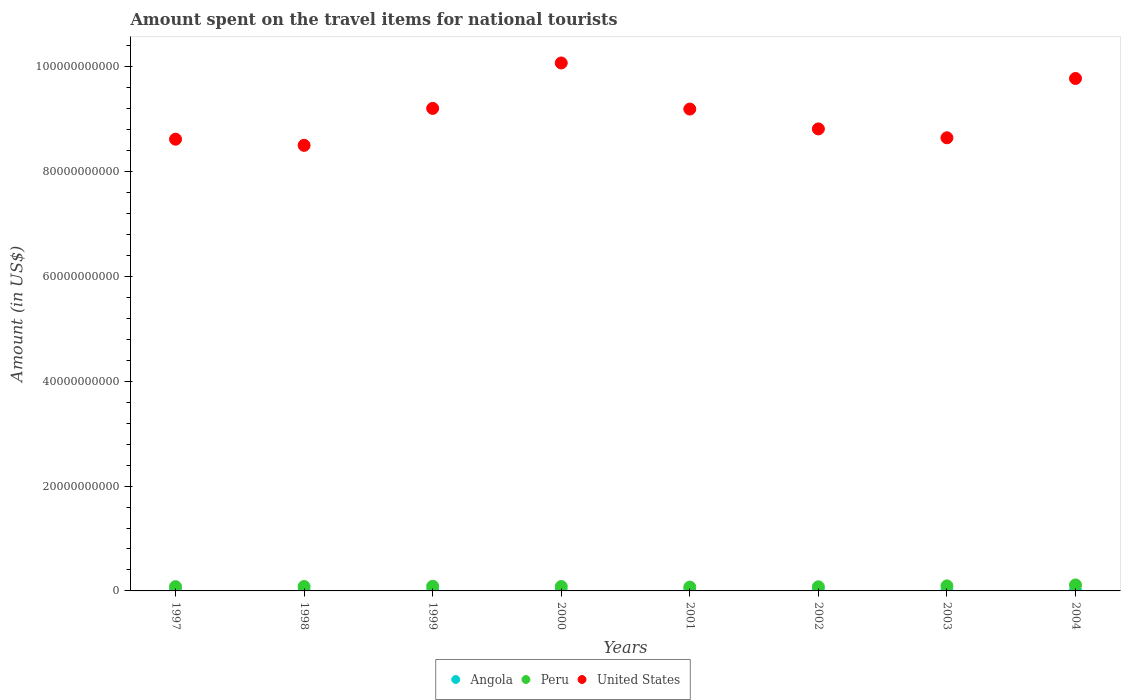Is the number of dotlines equal to the number of legend labels?
Make the answer very short. Yes. What is the amount spent on the travel items for national tourists in Peru in 2001?
Give a very brief answer. 7.33e+08. Across all years, what is the maximum amount spent on the travel items for national tourists in United States?
Ensure brevity in your answer.  1.01e+11. Across all years, what is the minimum amount spent on the travel items for national tourists in Peru?
Your answer should be compact. 7.33e+08. In which year was the amount spent on the travel items for national tourists in Angola maximum?
Your answer should be compact. 2004. In which year was the amount spent on the travel items for national tourists in Angola minimum?
Your answer should be very brief. 1998. What is the total amount spent on the travel items for national tourists in United States in the graph?
Keep it short and to the point. 7.28e+11. What is the difference between the amount spent on the travel items for national tourists in United States in 1998 and that in 2004?
Make the answer very short. -1.28e+1. What is the difference between the amount spent on the travel items for national tourists in Peru in 2004 and the amount spent on the travel items for national tourists in Angola in 1999?
Provide a succinct answer. 1.13e+09. What is the average amount spent on the travel items for national tourists in Angola per year?
Provide a succinct answer. 2.78e+07. In the year 2001, what is the difference between the amount spent on the travel items for national tourists in United States and amount spent on the travel items for national tourists in Peru?
Provide a short and direct response. 9.12e+1. What is the ratio of the amount spent on the travel items for national tourists in Peru in 2000 to that in 2004?
Provide a succinct answer. 0.73. Is the amount spent on the travel items for national tourists in United States in 1997 less than that in 2004?
Provide a short and direct response. Yes. Is the difference between the amount spent on the travel items for national tourists in United States in 1999 and 2000 greater than the difference between the amount spent on the travel items for national tourists in Peru in 1999 and 2000?
Your answer should be very brief. No. What is the difference between the highest and the second highest amount spent on the travel items for national tourists in Peru?
Provide a short and direct response. 1.79e+08. What is the difference between the highest and the lowest amount spent on the travel items for national tourists in United States?
Keep it short and to the point. 1.57e+1. Is the sum of the amount spent on the travel items for national tourists in United States in 1999 and 2003 greater than the maximum amount spent on the travel items for national tourists in Angola across all years?
Make the answer very short. Yes. Is the amount spent on the travel items for national tourists in Peru strictly less than the amount spent on the travel items for national tourists in United States over the years?
Offer a terse response. Yes. How many years are there in the graph?
Your response must be concise. 8. Are the values on the major ticks of Y-axis written in scientific E-notation?
Your response must be concise. No. Where does the legend appear in the graph?
Keep it short and to the point. Bottom center. What is the title of the graph?
Provide a short and direct response. Amount spent on the travel items for national tourists. What is the label or title of the X-axis?
Offer a terse response. Years. What is the Amount (in US$) in Angola in 1997?
Offer a very short reply. 9.00e+06. What is the Amount (in US$) in Peru in 1997?
Make the answer very short. 8.16e+08. What is the Amount (in US$) of United States in 1997?
Give a very brief answer. 8.62e+1. What is the Amount (in US$) of Peru in 1998?
Provide a succinct answer. 8.45e+08. What is the Amount (in US$) in United States in 1998?
Your response must be concise. 8.50e+1. What is the Amount (in US$) of Angola in 1999?
Ensure brevity in your answer.  1.30e+07. What is the Amount (in US$) of Peru in 1999?
Give a very brief answer. 8.90e+08. What is the Amount (in US$) of United States in 1999?
Your answer should be compact. 9.20e+1. What is the Amount (in US$) in Angola in 2000?
Provide a succinct answer. 1.80e+07. What is the Amount (in US$) in Peru in 2000?
Provide a succinct answer. 8.37e+08. What is the Amount (in US$) of United States in 2000?
Your response must be concise. 1.01e+11. What is the Amount (in US$) of Angola in 2001?
Provide a short and direct response. 2.20e+07. What is the Amount (in US$) in Peru in 2001?
Make the answer very short. 7.33e+08. What is the Amount (in US$) in United States in 2001?
Keep it short and to the point. 9.19e+1. What is the Amount (in US$) in Angola in 2002?
Provide a succinct answer. 3.70e+07. What is the Amount (in US$) in Peru in 2002?
Provide a short and direct response. 7.87e+08. What is the Amount (in US$) of United States in 2002?
Ensure brevity in your answer.  8.81e+1. What is the Amount (in US$) in Angola in 2003?
Make the answer very short. 4.90e+07. What is the Amount (in US$) in Peru in 2003?
Your answer should be very brief. 9.63e+08. What is the Amount (in US$) in United States in 2003?
Ensure brevity in your answer.  8.64e+1. What is the Amount (in US$) in Angola in 2004?
Your answer should be very brief. 6.60e+07. What is the Amount (in US$) in Peru in 2004?
Offer a terse response. 1.14e+09. What is the Amount (in US$) in United States in 2004?
Your answer should be very brief. 9.78e+1. Across all years, what is the maximum Amount (in US$) in Angola?
Your answer should be very brief. 6.60e+07. Across all years, what is the maximum Amount (in US$) in Peru?
Your answer should be very brief. 1.14e+09. Across all years, what is the maximum Amount (in US$) of United States?
Your answer should be compact. 1.01e+11. Across all years, what is the minimum Amount (in US$) of Peru?
Ensure brevity in your answer.  7.33e+08. Across all years, what is the minimum Amount (in US$) of United States?
Keep it short and to the point. 8.50e+1. What is the total Amount (in US$) of Angola in the graph?
Give a very brief answer. 2.22e+08. What is the total Amount (in US$) of Peru in the graph?
Provide a short and direct response. 7.01e+09. What is the total Amount (in US$) of United States in the graph?
Provide a succinct answer. 7.28e+11. What is the difference between the Amount (in US$) in Angola in 1997 and that in 1998?
Your response must be concise. 1.00e+06. What is the difference between the Amount (in US$) in Peru in 1997 and that in 1998?
Provide a succinct answer. -2.90e+07. What is the difference between the Amount (in US$) in United States in 1997 and that in 1998?
Offer a terse response. 1.17e+09. What is the difference between the Amount (in US$) of Angola in 1997 and that in 1999?
Provide a succinct answer. -4.00e+06. What is the difference between the Amount (in US$) of Peru in 1997 and that in 1999?
Keep it short and to the point. -7.40e+07. What is the difference between the Amount (in US$) of United States in 1997 and that in 1999?
Provide a short and direct response. -5.88e+09. What is the difference between the Amount (in US$) of Angola in 1997 and that in 2000?
Offer a very short reply. -9.00e+06. What is the difference between the Amount (in US$) in Peru in 1997 and that in 2000?
Your answer should be compact. -2.10e+07. What is the difference between the Amount (in US$) of United States in 1997 and that in 2000?
Provide a succinct answer. -1.45e+1. What is the difference between the Amount (in US$) in Angola in 1997 and that in 2001?
Your answer should be very brief. -1.30e+07. What is the difference between the Amount (in US$) in Peru in 1997 and that in 2001?
Provide a short and direct response. 8.30e+07. What is the difference between the Amount (in US$) in United States in 1997 and that in 2001?
Give a very brief answer. -5.75e+09. What is the difference between the Amount (in US$) of Angola in 1997 and that in 2002?
Ensure brevity in your answer.  -2.80e+07. What is the difference between the Amount (in US$) in Peru in 1997 and that in 2002?
Give a very brief answer. 2.90e+07. What is the difference between the Amount (in US$) of United States in 1997 and that in 2002?
Give a very brief answer. -1.96e+09. What is the difference between the Amount (in US$) in Angola in 1997 and that in 2003?
Your answer should be very brief. -4.00e+07. What is the difference between the Amount (in US$) of Peru in 1997 and that in 2003?
Make the answer very short. -1.47e+08. What is the difference between the Amount (in US$) in United States in 1997 and that in 2003?
Your response must be concise. -2.69e+08. What is the difference between the Amount (in US$) in Angola in 1997 and that in 2004?
Offer a terse response. -5.70e+07. What is the difference between the Amount (in US$) of Peru in 1997 and that in 2004?
Keep it short and to the point. -3.26e+08. What is the difference between the Amount (in US$) in United States in 1997 and that in 2004?
Make the answer very short. -1.16e+1. What is the difference between the Amount (in US$) in Angola in 1998 and that in 1999?
Your response must be concise. -5.00e+06. What is the difference between the Amount (in US$) of Peru in 1998 and that in 1999?
Offer a very short reply. -4.50e+07. What is the difference between the Amount (in US$) of United States in 1998 and that in 1999?
Your answer should be very brief. -7.05e+09. What is the difference between the Amount (in US$) in Angola in 1998 and that in 2000?
Offer a terse response. -1.00e+07. What is the difference between the Amount (in US$) in Peru in 1998 and that in 2000?
Ensure brevity in your answer.  8.00e+06. What is the difference between the Amount (in US$) in United States in 1998 and that in 2000?
Give a very brief answer. -1.57e+1. What is the difference between the Amount (in US$) in Angola in 1998 and that in 2001?
Provide a short and direct response. -1.40e+07. What is the difference between the Amount (in US$) of Peru in 1998 and that in 2001?
Your response must be concise. 1.12e+08. What is the difference between the Amount (in US$) of United States in 1998 and that in 2001?
Give a very brief answer. -6.92e+09. What is the difference between the Amount (in US$) in Angola in 1998 and that in 2002?
Offer a terse response. -2.90e+07. What is the difference between the Amount (in US$) of Peru in 1998 and that in 2002?
Make the answer very short. 5.80e+07. What is the difference between the Amount (in US$) of United States in 1998 and that in 2002?
Provide a short and direct response. -3.14e+09. What is the difference between the Amount (in US$) of Angola in 1998 and that in 2003?
Provide a succinct answer. -4.10e+07. What is the difference between the Amount (in US$) in Peru in 1998 and that in 2003?
Your answer should be very brief. -1.18e+08. What is the difference between the Amount (in US$) of United States in 1998 and that in 2003?
Provide a short and direct response. -1.44e+09. What is the difference between the Amount (in US$) in Angola in 1998 and that in 2004?
Offer a terse response. -5.80e+07. What is the difference between the Amount (in US$) in Peru in 1998 and that in 2004?
Your response must be concise. -2.97e+08. What is the difference between the Amount (in US$) in United States in 1998 and that in 2004?
Your response must be concise. -1.28e+1. What is the difference between the Amount (in US$) in Angola in 1999 and that in 2000?
Offer a very short reply. -5.00e+06. What is the difference between the Amount (in US$) of Peru in 1999 and that in 2000?
Keep it short and to the point. 5.30e+07. What is the difference between the Amount (in US$) of United States in 1999 and that in 2000?
Your answer should be very brief. -8.67e+09. What is the difference between the Amount (in US$) of Angola in 1999 and that in 2001?
Your answer should be very brief. -9.00e+06. What is the difference between the Amount (in US$) in Peru in 1999 and that in 2001?
Provide a succinct answer. 1.57e+08. What is the difference between the Amount (in US$) of United States in 1999 and that in 2001?
Provide a succinct answer. 1.28e+08. What is the difference between the Amount (in US$) in Angola in 1999 and that in 2002?
Your response must be concise. -2.40e+07. What is the difference between the Amount (in US$) of Peru in 1999 and that in 2002?
Your response must be concise. 1.03e+08. What is the difference between the Amount (in US$) of United States in 1999 and that in 2002?
Keep it short and to the point. 3.91e+09. What is the difference between the Amount (in US$) of Angola in 1999 and that in 2003?
Your answer should be very brief. -3.60e+07. What is the difference between the Amount (in US$) of Peru in 1999 and that in 2003?
Provide a succinct answer. -7.30e+07. What is the difference between the Amount (in US$) of United States in 1999 and that in 2003?
Offer a terse response. 5.61e+09. What is the difference between the Amount (in US$) of Angola in 1999 and that in 2004?
Your answer should be very brief. -5.30e+07. What is the difference between the Amount (in US$) of Peru in 1999 and that in 2004?
Make the answer very short. -2.52e+08. What is the difference between the Amount (in US$) in United States in 1999 and that in 2004?
Keep it short and to the point. -5.71e+09. What is the difference between the Amount (in US$) in Angola in 2000 and that in 2001?
Your response must be concise. -4.00e+06. What is the difference between the Amount (in US$) of Peru in 2000 and that in 2001?
Your answer should be very brief. 1.04e+08. What is the difference between the Amount (in US$) of United States in 2000 and that in 2001?
Ensure brevity in your answer.  8.79e+09. What is the difference between the Amount (in US$) of Angola in 2000 and that in 2002?
Give a very brief answer. -1.90e+07. What is the difference between the Amount (in US$) in United States in 2000 and that in 2002?
Offer a very short reply. 1.26e+1. What is the difference between the Amount (in US$) of Angola in 2000 and that in 2003?
Keep it short and to the point. -3.10e+07. What is the difference between the Amount (in US$) of Peru in 2000 and that in 2003?
Provide a succinct answer. -1.26e+08. What is the difference between the Amount (in US$) of United States in 2000 and that in 2003?
Your answer should be very brief. 1.43e+1. What is the difference between the Amount (in US$) in Angola in 2000 and that in 2004?
Your answer should be compact. -4.80e+07. What is the difference between the Amount (in US$) in Peru in 2000 and that in 2004?
Give a very brief answer. -3.05e+08. What is the difference between the Amount (in US$) in United States in 2000 and that in 2004?
Your answer should be very brief. 2.96e+09. What is the difference between the Amount (in US$) in Angola in 2001 and that in 2002?
Provide a succinct answer. -1.50e+07. What is the difference between the Amount (in US$) in Peru in 2001 and that in 2002?
Ensure brevity in your answer.  -5.40e+07. What is the difference between the Amount (in US$) of United States in 2001 and that in 2002?
Your answer should be compact. 3.79e+09. What is the difference between the Amount (in US$) in Angola in 2001 and that in 2003?
Your answer should be compact. -2.70e+07. What is the difference between the Amount (in US$) in Peru in 2001 and that in 2003?
Keep it short and to the point. -2.30e+08. What is the difference between the Amount (in US$) in United States in 2001 and that in 2003?
Ensure brevity in your answer.  5.48e+09. What is the difference between the Amount (in US$) in Angola in 2001 and that in 2004?
Provide a short and direct response. -4.40e+07. What is the difference between the Amount (in US$) in Peru in 2001 and that in 2004?
Make the answer very short. -4.09e+08. What is the difference between the Amount (in US$) of United States in 2001 and that in 2004?
Your response must be concise. -5.84e+09. What is the difference between the Amount (in US$) of Angola in 2002 and that in 2003?
Offer a terse response. -1.20e+07. What is the difference between the Amount (in US$) of Peru in 2002 and that in 2003?
Provide a short and direct response. -1.76e+08. What is the difference between the Amount (in US$) of United States in 2002 and that in 2003?
Your answer should be compact. 1.69e+09. What is the difference between the Amount (in US$) of Angola in 2002 and that in 2004?
Your response must be concise. -2.90e+07. What is the difference between the Amount (in US$) of Peru in 2002 and that in 2004?
Your response must be concise. -3.55e+08. What is the difference between the Amount (in US$) in United States in 2002 and that in 2004?
Your answer should be very brief. -9.62e+09. What is the difference between the Amount (in US$) in Angola in 2003 and that in 2004?
Provide a short and direct response. -1.70e+07. What is the difference between the Amount (in US$) of Peru in 2003 and that in 2004?
Give a very brief answer. -1.79e+08. What is the difference between the Amount (in US$) in United States in 2003 and that in 2004?
Give a very brief answer. -1.13e+1. What is the difference between the Amount (in US$) in Angola in 1997 and the Amount (in US$) in Peru in 1998?
Ensure brevity in your answer.  -8.36e+08. What is the difference between the Amount (in US$) of Angola in 1997 and the Amount (in US$) of United States in 1998?
Your answer should be compact. -8.50e+1. What is the difference between the Amount (in US$) in Peru in 1997 and the Amount (in US$) in United States in 1998?
Your response must be concise. -8.42e+1. What is the difference between the Amount (in US$) of Angola in 1997 and the Amount (in US$) of Peru in 1999?
Your response must be concise. -8.81e+08. What is the difference between the Amount (in US$) in Angola in 1997 and the Amount (in US$) in United States in 1999?
Keep it short and to the point. -9.20e+1. What is the difference between the Amount (in US$) of Peru in 1997 and the Amount (in US$) of United States in 1999?
Provide a short and direct response. -9.12e+1. What is the difference between the Amount (in US$) of Angola in 1997 and the Amount (in US$) of Peru in 2000?
Give a very brief answer. -8.28e+08. What is the difference between the Amount (in US$) in Angola in 1997 and the Amount (in US$) in United States in 2000?
Ensure brevity in your answer.  -1.01e+11. What is the difference between the Amount (in US$) in Peru in 1997 and the Amount (in US$) in United States in 2000?
Ensure brevity in your answer.  -9.99e+1. What is the difference between the Amount (in US$) in Angola in 1997 and the Amount (in US$) in Peru in 2001?
Your answer should be compact. -7.24e+08. What is the difference between the Amount (in US$) of Angola in 1997 and the Amount (in US$) of United States in 2001?
Make the answer very short. -9.19e+1. What is the difference between the Amount (in US$) in Peru in 1997 and the Amount (in US$) in United States in 2001?
Your answer should be compact. -9.11e+1. What is the difference between the Amount (in US$) of Angola in 1997 and the Amount (in US$) of Peru in 2002?
Your answer should be very brief. -7.78e+08. What is the difference between the Amount (in US$) of Angola in 1997 and the Amount (in US$) of United States in 2002?
Your response must be concise. -8.81e+1. What is the difference between the Amount (in US$) in Peru in 1997 and the Amount (in US$) in United States in 2002?
Give a very brief answer. -8.73e+1. What is the difference between the Amount (in US$) of Angola in 1997 and the Amount (in US$) of Peru in 2003?
Your response must be concise. -9.54e+08. What is the difference between the Amount (in US$) in Angola in 1997 and the Amount (in US$) in United States in 2003?
Make the answer very short. -8.64e+1. What is the difference between the Amount (in US$) in Peru in 1997 and the Amount (in US$) in United States in 2003?
Keep it short and to the point. -8.56e+1. What is the difference between the Amount (in US$) in Angola in 1997 and the Amount (in US$) in Peru in 2004?
Your response must be concise. -1.13e+09. What is the difference between the Amount (in US$) in Angola in 1997 and the Amount (in US$) in United States in 2004?
Offer a terse response. -9.77e+1. What is the difference between the Amount (in US$) in Peru in 1997 and the Amount (in US$) in United States in 2004?
Your response must be concise. -9.69e+1. What is the difference between the Amount (in US$) of Angola in 1998 and the Amount (in US$) of Peru in 1999?
Provide a short and direct response. -8.82e+08. What is the difference between the Amount (in US$) of Angola in 1998 and the Amount (in US$) of United States in 1999?
Make the answer very short. -9.20e+1. What is the difference between the Amount (in US$) in Peru in 1998 and the Amount (in US$) in United States in 1999?
Make the answer very short. -9.12e+1. What is the difference between the Amount (in US$) in Angola in 1998 and the Amount (in US$) in Peru in 2000?
Ensure brevity in your answer.  -8.29e+08. What is the difference between the Amount (in US$) of Angola in 1998 and the Amount (in US$) of United States in 2000?
Your answer should be compact. -1.01e+11. What is the difference between the Amount (in US$) in Peru in 1998 and the Amount (in US$) in United States in 2000?
Your answer should be very brief. -9.99e+1. What is the difference between the Amount (in US$) in Angola in 1998 and the Amount (in US$) in Peru in 2001?
Your answer should be very brief. -7.25e+08. What is the difference between the Amount (in US$) of Angola in 1998 and the Amount (in US$) of United States in 2001?
Your answer should be very brief. -9.19e+1. What is the difference between the Amount (in US$) in Peru in 1998 and the Amount (in US$) in United States in 2001?
Provide a short and direct response. -9.11e+1. What is the difference between the Amount (in US$) in Angola in 1998 and the Amount (in US$) in Peru in 2002?
Ensure brevity in your answer.  -7.79e+08. What is the difference between the Amount (in US$) in Angola in 1998 and the Amount (in US$) in United States in 2002?
Provide a short and direct response. -8.81e+1. What is the difference between the Amount (in US$) in Peru in 1998 and the Amount (in US$) in United States in 2002?
Your response must be concise. -8.73e+1. What is the difference between the Amount (in US$) of Angola in 1998 and the Amount (in US$) of Peru in 2003?
Offer a terse response. -9.55e+08. What is the difference between the Amount (in US$) in Angola in 1998 and the Amount (in US$) in United States in 2003?
Offer a terse response. -8.64e+1. What is the difference between the Amount (in US$) in Peru in 1998 and the Amount (in US$) in United States in 2003?
Your answer should be very brief. -8.56e+1. What is the difference between the Amount (in US$) in Angola in 1998 and the Amount (in US$) in Peru in 2004?
Ensure brevity in your answer.  -1.13e+09. What is the difference between the Amount (in US$) in Angola in 1998 and the Amount (in US$) in United States in 2004?
Your answer should be very brief. -9.78e+1. What is the difference between the Amount (in US$) of Peru in 1998 and the Amount (in US$) of United States in 2004?
Provide a short and direct response. -9.69e+1. What is the difference between the Amount (in US$) in Angola in 1999 and the Amount (in US$) in Peru in 2000?
Your answer should be compact. -8.24e+08. What is the difference between the Amount (in US$) of Angola in 1999 and the Amount (in US$) of United States in 2000?
Offer a very short reply. -1.01e+11. What is the difference between the Amount (in US$) in Peru in 1999 and the Amount (in US$) in United States in 2000?
Keep it short and to the point. -9.98e+1. What is the difference between the Amount (in US$) of Angola in 1999 and the Amount (in US$) of Peru in 2001?
Make the answer very short. -7.20e+08. What is the difference between the Amount (in US$) of Angola in 1999 and the Amount (in US$) of United States in 2001?
Your response must be concise. -9.19e+1. What is the difference between the Amount (in US$) in Peru in 1999 and the Amount (in US$) in United States in 2001?
Offer a very short reply. -9.10e+1. What is the difference between the Amount (in US$) in Angola in 1999 and the Amount (in US$) in Peru in 2002?
Provide a short and direct response. -7.74e+08. What is the difference between the Amount (in US$) of Angola in 1999 and the Amount (in US$) of United States in 2002?
Give a very brief answer. -8.81e+1. What is the difference between the Amount (in US$) of Peru in 1999 and the Amount (in US$) of United States in 2002?
Offer a terse response. -8.72e+1. What is the difference between the Amount (in US$) of Angola in 1999 and the Amount (in US$) of Peru in 2003?
Make the answer very short. -9.50e+08. What is the difference between the Amount (in US$) of Angola in 1999 and the Amount (in US$) of United States in 2003?
Offer a very short reply. -8.64e+1. What is the difference between the Amount (in US$) in Peru in 1999 and the Amount (in US$) in United States in 2003?
Offer a terse response. -8.56e+1. What is the difference between the Amount (in US$) of Angola in 1999 and the Amount (in US$) of Peru in 2004?
Offer a terse response. -1.13e+09. What is the difference between the Amount (in US$) of Angola in 1999 and the Amount (in US$) of United States in 2004?
Your answer should be compact. -9.77e+1. What is the difference between the Amount (in US$) of Peru in 1999 and the Amount (in US$) of United States in 2004?
Give a very brief answer. -9.69e+1. What is the difference between the Amount (in US$) of Angola in 2000 and the Amount (in US$) of Peru in 2001?
Your answer should be very brief. -7.15e+08. What is the difference between the Amount (in US$) in Angola in 2000 and the Amount (in US$) in United States in 2001?
Your answer should be very brief. -9.19e+1. What is the difference between the Amount (in US$) of Peru in 2000 and the Amount (in US$) of United States in 2001?
Make the answer very short. -9.11e+1. What is the difference between the Amount (in US$) of Angola in 2000 and the Amount (in US$) of Peru in 2002?
Provide a short and direct response. -7.69e+08. What is the difference between the Amount (in US$) in Angola in 2000 and the Amount (in US$) in United States in 2002?
Ensure brevity in your answer.  -8.81e+1. What is the difference between the Amount (in US$) of Peru in 2000 and the Amount (in US$) of United States in 2002?
Provide a succinct answer. -8.73e+1. What is the difference between the Amount (in US$) of Angola in 2000 and the Amount (in US$) of Peru in 2003?
Ensure brevity in your answer.  -9.45e+08. What is the difference between the Amount (in US$) in Angola in 2000 and the Amount (in US$) in United States in 2003?
Your answer should be very brief. -8.64e+1. What is the difference between the Amount (in US$) of Peru in 2000 and the Amount (in US$) of United States in 2003?
Provide a succinct answer. -8.56e+1. What is the difference between the Amount (in US$) in Angola in 2000 and the Amount (in US$) in Peru in 2004?
Provide a succinct answer. -1.12e+09. What is the difference between the Amount (in US$) in Angola in 2000 and the Amount (in US$) in United States in 2004?
Offer a terse response. -9.77e+1. What is the difference between the Amount (in US$) in Peru in 2000 and the Amount (in US$) in United States in 2004?
Your answer should be compact. -9.69e+1. What is the difference between the Amount (in US$) in Angola in 2001 and the Amount (in US$) in Peru in 2002?
Your answer should be compact. -7.65e+08. What is the difference between the Amount (in US$) in Angola in 2001 and the Amount (in US$) in United States in 2002?
Ensure brevity in your answer.  -8.81e+1. What is the difference between the Amount (in US$) in Peru in 2001 and the Amount (in US$) in United States in 2002?
Your response must be concise. -8.74e+1. What is the difference between the Amount (in US$) of Angola in 2001 and the Amount (in US$) of Peru in 2003?
Provide a succinct answer. -9.41e+08. What is the difference between the Amount (in US$) in Angola in 2001 and the Amount (in US$) in United States in 2003?
Make the answer very short. -8.64e+1. What is the difference between the Amount (in US$) of Peru in 2001 and the Amount (in US$) of United States in 2003?
Offer a very short reply. -8.57e+1. What is the difference between the Amount (in US$) of Angola in 2001 and the Amount (in US$) of Peru in 2004?
Provide a succinct answer. -1.12e+09. What is the difference between the Amount (in US$) in Angola in 2001 and the Amount (in US$) in United States in 2004?
Your answer should be compact. -9.77e+1. What is the difference between the Amount (in US$) in Peru in 2001 and the Amount (in US$) in United States in 2004?
Ensure brevity in your answer.  -9.70e+1. What is the difference between the Amount (in US$) of Angola in 2002 and the Amount (in US$) of Peru in 2003?
Give a very brief answer. -9.26e+08. What is the difference between the Amount (in US$) in Angola in 2002 and the Amount (in US$) in United States in 2003?
Provide a short and direct response. -8.64e+1. What is the difference between the Amount (in US$) in Peru in 2002 and the Amount (in US$) in United States in 2003?
Ensure brevity in your answer.  -8.57e+1. What is the difference between the Amount (in US$) in Angola in 2002 and the Amount (in US$) in Peru in 2004?
Provide a short and direct response. -1.10e+09. What is the difference between the Amount (in US$) of Angola in 2002 and the Amount (in US$) of United States in 2004?
Your answer should be very brief. -9.77e+1. What is the difference between the Amount (in US$) in Peru in 2002 and the Amount (in US$) in United States in 2004?
Give a very brief answer. -9.70e+1. What is the difference between the Amount (in US$) of Angola in 2003 and the Amount (in US$) of Peru in 2004?
Provide a short and direct response. -1.09e+09. What is the difference between the Amount (in US$) of Angola in 2003 and the Amount (in US$) of United States in 2004?
Provide a short and direct response. -9.77e+1. What is the difference between the Amount (in US$) of Peru in 2003 and the Amount (in US$) of United States in 2004?
Make the answer very short. -9.68e+1. What is the average Amount (in US$) in Angola per year?
Make the answer very short. 2.78e+07. What is the average Amount (in US$) of Peru per year?
Offer a very short reply. 8.77e+08. What is the average Amount (in US$) in United States per year?
Provide a short and direct response. 9.10e+1. In the year 1997, what is the difference between the Amount (in US$) in Angola and Amount (in US$) in Peru?
Make the answer very short. -8.07e+08. In the year 1997, what is the difference between the Amount (in US$) in Angola and Amount (in US$) in United States?
Keep it short and to the point. -8.62e+1. In the year 1997, what is the difference between the Amount (in US$) in Peru and Amount (in US$) in United States?
Offer a terse response. -8.54e+1. In the year 1998, what is the difference between the Amount (in US$) in Angola and Amount (in US$) in Peru?
Provide a short and direct response. -8.37e+08. In the year 1998, what is the difference between the Amount (in US$) in Angola and Amount (in US$) in United States?
Offer a terse response. -8.50e+1. In the year 1998, what is the difference between the Amount (in US$) in Peru and Amount (in US$) in United States?
Give a very brief answer. -8.42e+1. In the year 1999, what is the difference between the Amount (in US$) of Angola and Amount (in US$) of Peru?
Provide a short and direct response. -8.77e+08. In the year 1999, what is the difference between the Amount (in US$) of Angola and Amount (in US$) of United States?
Provide a succinct answer. -9.20e+1. In the year 1999, what is the difference between the Amount (in US$) in Peru and Amount (in US$) in United States?
Offer a very short reply. -9.12e+1. In the year 2000, what is the difference between the Amount (in US$) of Angola and Amount (in US$) of Peru?
Give a very brief answer. -8.19e+08. In the year 2000, what is the difference between the Amount (in US$) in Angola and Amount (in US$) in United States?
Offer a terse response. -1.01e+11. In the year 2000, what is the difference between the Amount (in US$) of Peru and Amount (in US$) of United States?
Provide a short and direct response. -9.99e+1. In the year 2001, what is the difference between the Amount (in US$) in Angola and Amount (in US$) in Peru?
Your answer should be compact. -7.11e+08. In the year 2001, what is the difference between the Amount (in US$) in Angola and Amount (in US$) in United States?
Give a very brief answer. -9.19e+1. In the year 2001, what is the difference between the Amount (in US$) of Peru and Amount (in US$) of United States?
Give a very brief answer. -9.12e+1. In the year 2002, what is the difference between the Amount (in US$) of Angola and Amount (in US$) of Peru?
Keep it short and to the point. -7.50e+08. In the year 2002, what is the difference between the Amount (in US$) in Angola and Amount (in US$) in United States?
Ensure brevity in your answer.  -8.81e+1. In the year 2002, what is the difference between the Amount (in US$) in Peru and Amount (in US$) in United States?
Keep it short and to the point. -8.73e+1. In the year 2003, what is the difference between the Amount (in US$) in Angola and Amount (in US$) in Peru?
Ensure brevity in your answer.  -9.14e+08. In the year 2003, what is the difference between the Amount (in US$) in Angola and Amount (in US$) in United States?
Give a very brief answer. -8.64e+1. In the year 2003, what is the difference between the Amount (in US$) in Peru and Amount (in US$) in United States?
Your answer should be very brief. -8.55e+1. In the year 2004, what is the difference between the Amount (in US$) in Angola and Amount (in US$) in Peru?
Your answer should be very brief. -1.08e+09. In the year 2004, what is the difference between the Amount (in US$) of Angola and Amount (in US$) of United States?
Your answer should be compact. -9.77e+1. In the year 2004, what is the difference between the Amount (in US$) in Peru and Amount (in US$) in United States?
Keep it short and to the point. -9.66e+1. What is the ratio of the Amount (in US$) of Angola in 1997 to that in 1998?
Provide a short and direct response. 1.12. What is the ratio of the Amount (in US$) in Peru in 1997 to that in 1998?
Your answer should be very brief. 0.97. What is the ratio of the Amount (in US$) of United States in 1997 to that in 1998?
Provide a short and direct response. 1.01. What is the ratio of the Amount (in US$) of Angola in 1997 to that in 1999?
Your answer should be compact. 0.69. What is the ratio of the Amount (in US$) of Peru in 1997 to that in 1999?
Make the answer very short. 0.92. What is the ratio of the Amount (in US$) of United States in 1997 to that in 1999?
Your answer should be very brief. 0.94. What is the ratio of the Amount (in US$) in Peru in 1997 to that in 2000?
Make the answer very short. 0.97. What is the ratio of the Amount (in US$) in United States in 1997 to that in 2000?
Keep it short and to the point. 0.86. What is the ratio of the Amount (in US$) in Angola in 1997 to that in 2001?
Make the answer very short. 0.41. What is the ratio of the Amount (in US$) in Peru in 1997 to that in 2001?
Offer a terse response. 1.11. What is the ratio of the Amount (in US$) in Angola in 1997 to that in 2002?
Offer a very short reply. 0.24. What is the ratio of the Amount (in US$) in Peru in 1997 to that in 2002?
Provide a succinct answer. 1.04. What is the ratio of the Amount (in US$) in United States in 1997 to that in 2002?
Ensure brevity in your answer.  0.98. What is the ratio of the Amount (in US$) in Angola in 1997 to that in 2003?
Provide a succinct answer. 0.18. What is the ratio of the Amount (in US$) of Peru in 1997 to that in 2003?
Provide a short and direct response. 0.85. What is the ratio of the Amount (in US$) of United States in 1997 to that in 2003?
Your response must be concise. 1. What is the ratio of the Amount (in US$) of Angola in 1997 to that in 2004?
Offer a very short reply. 0.14. What is the ratio of the Amount (in US$) in Peru in 1997 to that in 2004?
Your answer should be very brief. 0.71. What is the ratio of the Amount (in US$) in United States in 1997 to that in 2004?
Provide a succinct answer. 0.88. What is the ratio of the Amount (in US$) of Angola in 1998 to that in 1999?
Provide a succinct answer. 0.62. What is the ratio of the Amount (in US$) of Peru in 1998 to that in 1999?
Ensure brevity in your answer.  0.95. What is the ratio of the Amount (in US$) of United States in 1998 to that in 1999?
Your answer should be very brief. 0.92. What is the ratio of the Amount (in US$) of Angola in 1998 to that in 2000?
Offer a terse response. 0.44. What is the ratio of the Amount (in US$) in Peru in 1998 to that in 2000?
Your answer should be very brief. 1.01. What is the ratio of the Amount (in US$) of United States in 1998 to that in 2000?
Offer a very short reply. 0.84. What is the ratio of the Amount (in US$) of Angola in 1998 to that in 2001?
Provide a short and direct response. 0.36. What is the ratio of the Amount (in US$) in Peru in 1998 to that in 2001?
Offer a terse response. 1.15. What is the ratio of the Amount (in US$) of United States in 1998 to that in 2001?
Provide a short and direct response. 0.92. What is the ratio of the Amount (in US$) in Angola in 1998 to that in 2002?
Ensure brevity in your answer.  0.22. What is the ratio of the Amount (in US$) in Peru in 1998 to that in 2002?
Ensure brevity in your answer.  1.07. What is the ratio of the Amount (in US$) in United States in 1998 to that in 2002?
Ensure brevity in your answer.  0.96. What is the ratio of the Amount (in US$) of Angola in 1998 to that in 2003?
Give a very brief answer. 0.16. What is the ratio of the Amount (in US$) of Peru in 1998 to that in 2003?
Provide a short and direct response. 0.88. What is the ratio of the Amount (in US$) in United States in 1998 to that in 2003?
Your response must be concise. 0.98. What is the ratio of the Amount (in US$) of Angola in 1998 to that in 2004?
Offer a very short reply. 0.12. What is the ratio of the Amount (in US$) of Peru in 1998 to that in 2004?
Keep it short and to the point. 0.74. What is the ratio of the Amount (in US$) of United States in 1998 to that in 2004?
Offer a very short reply. 0.87. What is the ratio of the Amount (in US$) in Angola in 1999 to that in 2000?
Ensure brevity in your answer.  0.72. What is the ratio of the Amount (in US$) in Peru in 1999 to that in 2000?
Ensure brevity in your answer.  1.06. What is the ratio of the Amount (in US$) in United States in 1999 to that in 2000?
Provide a succinct answer. 0.91. What is the ratio of the Amount (in US$) of Angola in 1999 to that in 2001?
Ensure brevity in your answer.  0.59. What is the ratio of the Amount (in US$) in Peru in 1999 to that in 2001?
Provide a succinct answer. 1.21. What is the ratio of the Amount (in US$) of Angola in 1999 to that in 2002?
Provide a succinct answer. 0.35. What is the ratio of the Amount (in US$) in Peru in 1999 to that in 2002?
Your answer should be compact. 1.13. What is the ratio of the Amount (in US$) in United States in 1999 to that in 2002?
Keep it short and to the point. 1.04. What is the ratio of the Amount (in US$) of Angola in 1999 to that in 2003?
Your answer should be very brief. 0.27. What is the ratio of the Amount (in US$) in Peru in 1999 to that in 2003?
Make the answer very short. 0.92. What is the ratio of the Amount (in US$) of United States in 1999 to that in 2003?
Ensure brevity in your answer.  1.06. What is the ratio of the Amount (in US$) of Angola in 1999 to that in 2004?
Your response must be concise. 0.2. What is the ratio of the Amount (in US$) of Peru in 1999 to that in 2004?
Provide a short and direct response. 0.78. What is the ratio of the Amount (in US$) of United States in 1999 to that in 2004?
Make the answer very short. 0.94. What is the ratio of the Amount (in US$) of Angola in 2000 to that in 2001?
Offer a terse response. 0.82. What is the ratio of the Amount (in US$) of Peru in 2000 to that in 2001?
Keep it short and to the point. 1.14. What is the ratio of the Amount (in US$) in United States in 2000 to that in 2001?
Provide a short and direct response. 1.1. What is the ratio of the Amount (in US$) of Angola in 2000 to that in 2002?
Your response must be concise. 0.49. What is the ratio of the Amount (in US$) in Peru in 2000 to that in 2002?
Offer a very short reply. 1.06. What is the ratio of the Amount (in US$) of United States in 2000 to that in 2002?
Offer a very short reply. 1.14. What is the ratio of the Amount (in US$) of Angola in 2000 to that in 2003?
Provide a succinct answer. 0.37. What is the ratio of the Amount (in US$) in Peru in 2000 to that in 2003?
Your response must be concise. 0.87. What is the ratio of the Amount (in US$) in United States in 2000 to that in 2003?
Offer a terse response. 1.17. What is the ratio of the Amount (in US$) of Angola in 2000 to that in 2004?
Ensure brevity in your answer.  0.27. What is the ratio of the Amount (in US$) in Peru in 2000 to that in 2004?
Offer a terse response. 0.73. What is the ratio of the Amount (in US$) in United States in 2000 to that in 2004?
Give a very brief answer. 1.03. What is the ratio of the Amount (in US$) of Angola in 2001 to that in 2002?
Provide a succinct answer. 0.59. What is the ratio of the Amount (in US$) of Peru in 2001 to that in 2002?
Ensure brevity in your answer.  0.93. What is the ratio of the Amount (in US$) in United States in 2001 to that in 2002?
Make the answer very short. 1.04. What is the ratio of the Amount (in US$) of Angola in 2001 to that in 2003?
Keep it short and to the point. 0.45. What is the ratio of the Amount (in US$) of Peru in 2001 to that in 2003?
Ensure brevity in your answer.  0.76. What is the ratio of the Amount (in US$) in United States in 2001 to that in 2003?
Your response must be concise. 1.06. What is the ratio of the Amount (in US$) in Peru in 2001 to that in 2004?
Provide a short and direct response. 0.64. What is the ratio of the Amount (in US$) in United States in 2001 to that in 2004?
Offer a very short reply. 0.94. What is the ratio of the Amount (in US$) of Angola in 2002 to that in 2003?
Your response must be concise. 0.76. What is the ratio of the Amount (in US$) of Peru in 2002 to that in 2003?
Provide a short and direct response. 0.82. What is the ratio of the Amount (in US$) in United States in 2002 to that in 2003?
Provide a succinct answer. 1.02. What is the ratio of the Amount (in US$) in Angola in 2002 to that in 2004?
Offer a very short reply. 0.56. What is the ratio of the Amount (in US$) in Peru in 2002 to that in 2004?
Offer a very short reply. 0.69. What is the ratio of the Amount (in US$) in United States in 2002 to that in 2004?
Give a very brief answer. 0.9. What is the ratio of the Amount (in US$) of Angola in 2003 to that in 2004?
Offer a very short reply. 0.74. What is the ratio of the Amount (in US$) of Peru in 2003 to that in 2004?
Offer a terse response. 0.84. What is the ratio of the Amount (in US$) in United States in 2003 to that in 2004?
Your answer should be compact. 0.88. What is the difference between the highest and the second highest Amount (in US$) in Angola?
Offer a terse response. 1.70e+07. What is the difference between the highest and the second highest Amount (in US$) of Peru?
Keep it short and to the point. 1.79e+08. What is the difference between the highest and the second highest Amount (in US$) of United States?
Provide a succinct answer. 2.96e+09. What is the difference between the highest and the lowest Amount (in US$) of Angola?
Your answer should be compact. 5.80e+07. What is the difference between the highest and the lowest Amount (in US$) of Peru?
Your answer should be very brief. 4.09e+08. What is the difference between the highest and the lowest Amount (in US$) in United States?
Make the answer very short. 1.57e+1. 